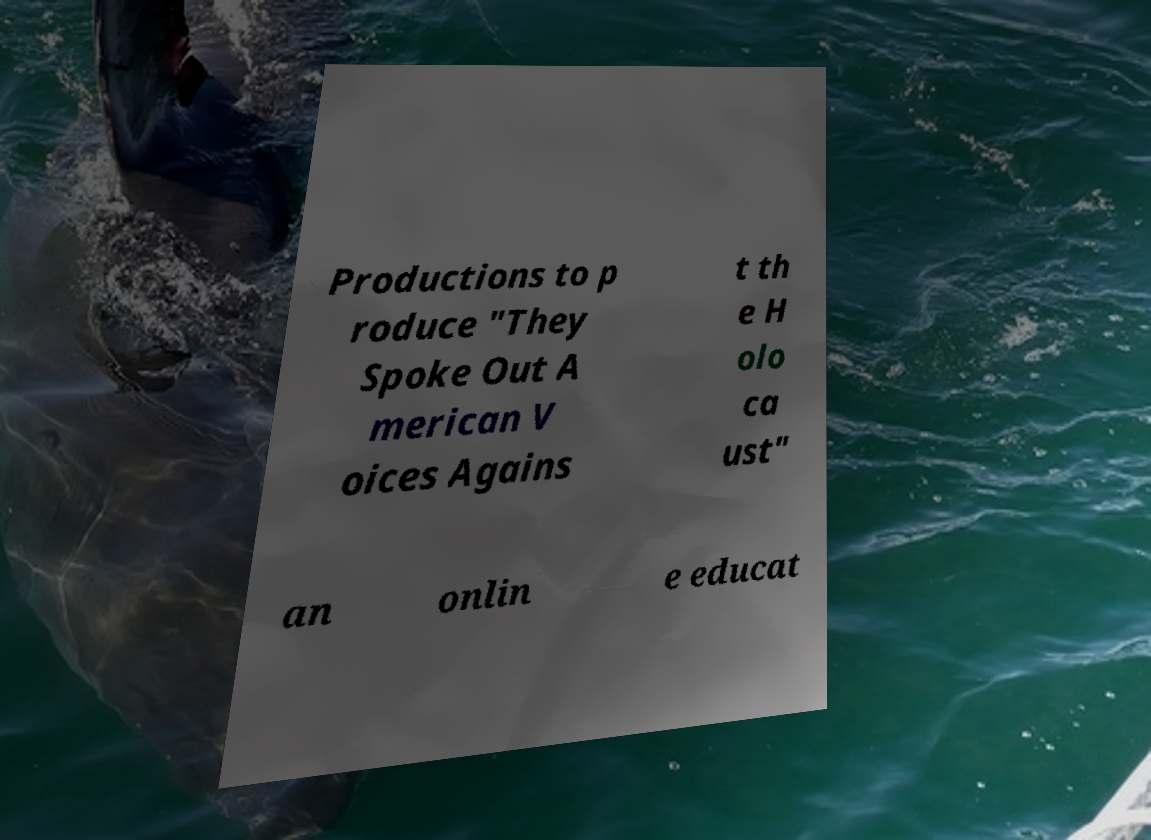For documentation purposes, I need the text within this image transcribed. Could you provide that? Productions to p roduce "They Spoke Out A merican V oices Agains t th e H olo ca ust" an onlin e educat 